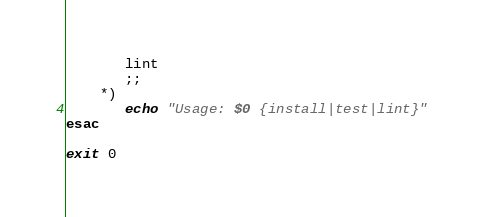<code> <loc_0><loc_0><loc_500><loc_500><_Bash_>       lint
       ;;
    *)
       echo "Usage: $0 {install|test|lint}"
esac

exit 0
</code> 